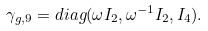Convert formula to latex. <formula><loc_0><loc_0><loc_500><loc_500>\gamma _ { g , 9 } = d i a g ( \omega I _ { 2 } , \omega ^ { - 1 } I _ { 2 } , I _ { 4 } ) .</formula> 